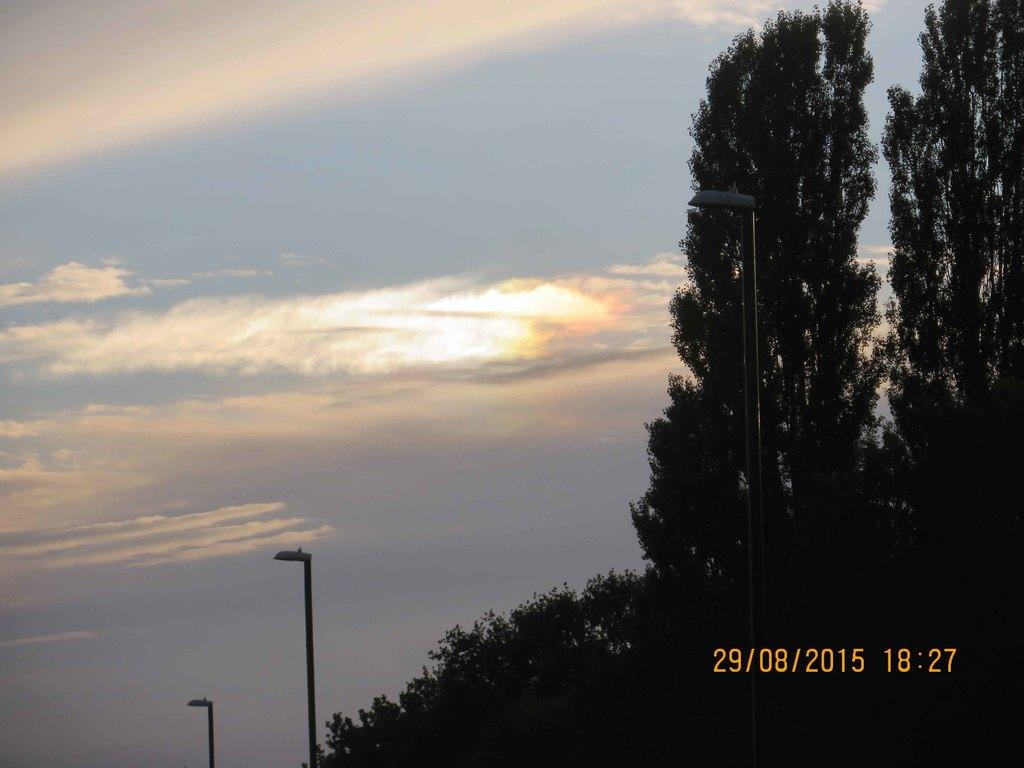What type of natural elements can be seen in the image? There are trees in the image. What man-made structures are present in the image? There are poles in the image. What additional objects can be seen in the image? There are lights in the image. What can be seen in the sky in the image? There are clouds in the image. Is there any information about when the image was taken? Yes, there is a timestamp at the right bottom of the image. What type of music can be heard playing in the image? There is no music present in the image, as it is a still photograph. Can you provide an example of a development that is visible in the image? There is no development or construction project visible in the image; it primarily features trees, poles, lights, clouds, and a timestamp. 